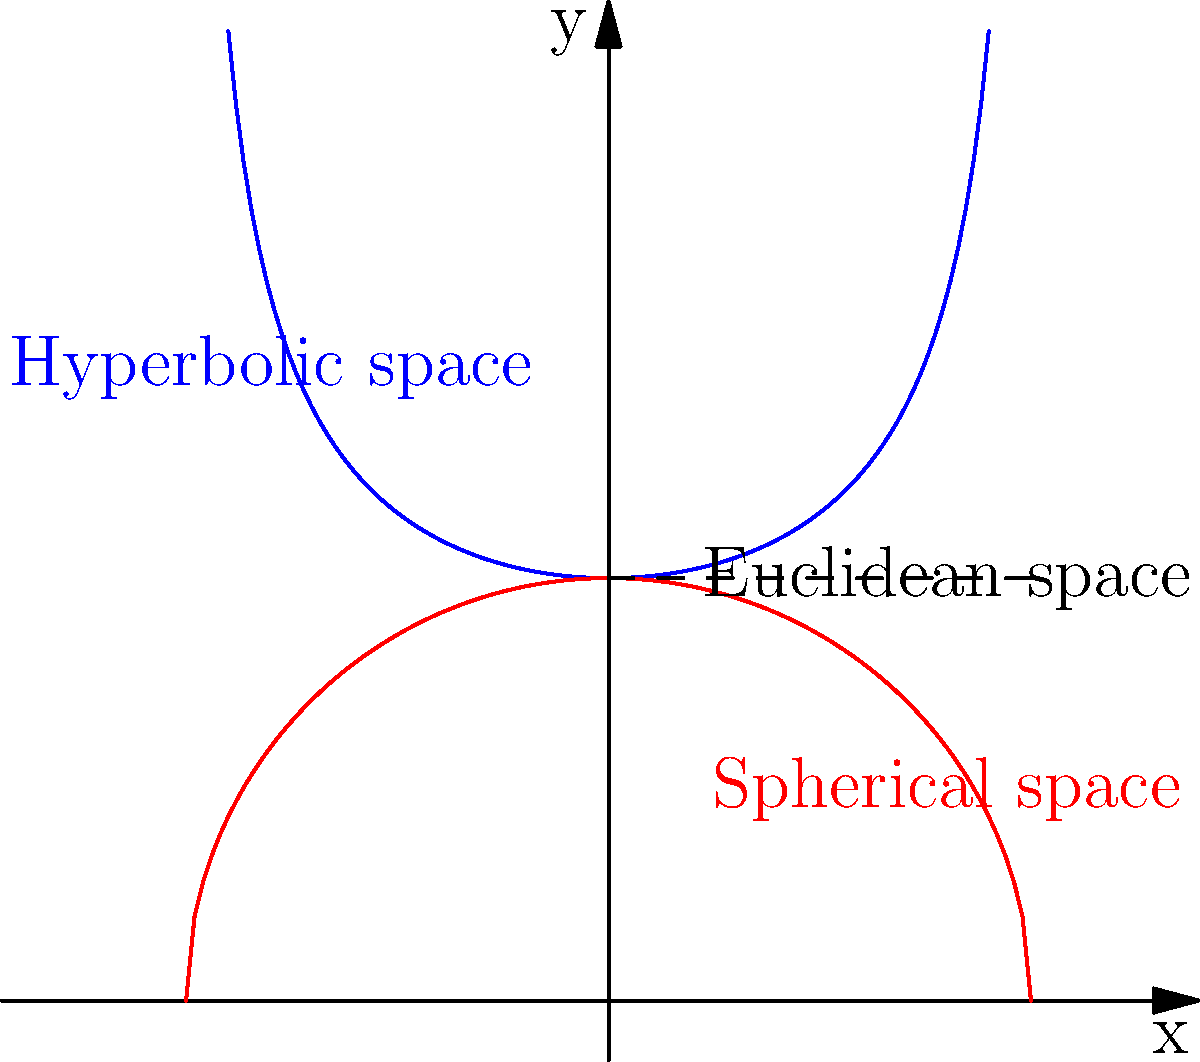In the context of environmental modeling, how does the curvature of space impact the calculation of distances and areas? Consider the graph showing different space curvatures (hyperbolic in blue, spherical in red, and Euclidean as the dashed line). How might these differences affect our understanding of habitat fragmentation and conservation efforts? To understand the impact of space curvature on environmental modeling, let's consider the following steps:

1. Euclidean space (flat):
   - In Euclidean geometry, the shortest distance between two points is a straight line.
   - Areas are calculated using familiar formulas (e.g., $A = \pi r^2$ for circles).

2. Spherical space (positive curvature):
   - On a sphere, the shortest path between two points is a great circle.
   - Areas on a sphere are larger than they appear on a flat projection.
   - The sum of angles in a triangle is > 180°.

3. Hyperbolic space (negative curvature):
   - In hyperbolic geometry, parallel lines diverge.
   - Areas in hyperbolic space are smaller than they appear in Euclidean projections.
   - The sum of angles in a triangle is < 180°.

4. Impact on distance calculations:
   - In spherical space: $d = R \arccos(\sin\phi_1\sin\phi_2 + \cos\phi_1\cos\phi_2\cos(\lambda_2-\lambda_1))$
     where $R$ is the radius, $\phi$ is latitude, and $\lambda$ is longitude.
   - In hyperbolic space: distances grow exponentially with linear movement.

5. Effects on environmental modeling:
   - Habitat fragmentation: The actual distance between habitat patches may be different from Euclidean estimates.
   - Conservation efforts: The true area of protected regions might be under or overestimated.
   - Species distribution: Range and dispersal models need to account for space curvature.

6. Practical implications:
   - Large-scale ecology: Earth's curvature becomes significant for continental or global studies.
   - Climate modeling: Accurate representation of atmospheric and oceanic currents requires non-Euclidean geometry.
   - Biodiversity hotspots: Prioritization of conservation areas may change when considering true spatial relationships.

Understanding these differences is crucial for developing more accurate environmental models and making informed decisions about conservation strategies and resource management.
Answer: Non-Euclidean geometry affects distance and area calculations, potentially leading to misestimations in habitat fragmentation, species distribution, and conservation planning if not accounted for in environmental models. 